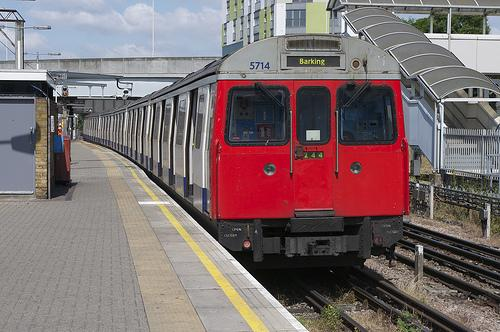State any safety measures taken on the platform. There is a yellow safety line on the platform. What type of vehicle is featured in this image? A train. How many lines on the road are there in the image? There are no lines on the road in the image, as it shows a train on tracks. Describe the image in terms of the environment and atmosphere. The image shows a train at a station with a clear blue sky and some clouds, metal structures overhead, and a clean platform. What is the primary sentiment of the image? The image has a neutral sentiment, showing a train at a station. Mention what color the train is and any peculiar features it has. The train is red and grey. Count the instances of grafitti found on the train. There is no visible graffiti on the train in the image. 